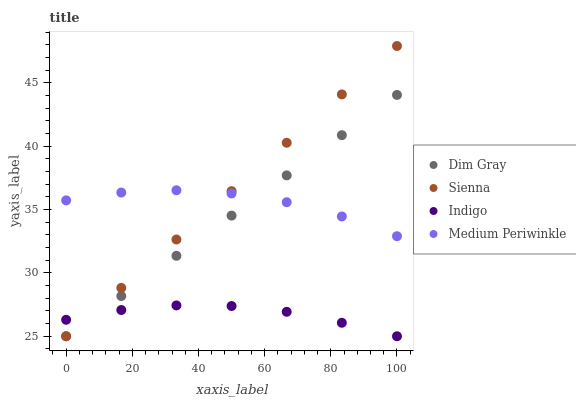Does Indigo have the minimum area under the curve?
Answer yes or no. Yes. Does Sienna have the maximum area under the curve?
Answer yes or no. Yes. Does Medium Periwinkle have the minimum area under the curve?
Answer yes or no. No. Does Medium Periwinkle have the maximum area under the curve?
Answer yes or no. No. Is Sienna the smoothest?
Answer yes or no. Yes. Is Medium Periwinkle the roughest?
Answer yes or no. Yes. Is Dim Gray the smoothest?
Answer yes or no. No. Is Dim Gray the roughest?
Answer yes or no. No. Does Sienna have the lowest value?
Answer yes or no. Yes. Does Medium Periwinkle have the lowest value?
Answer yes or no. No. Does Sienna have the highest value?
Answer yes or no. Yes. Does Medium Periwinkle have the highest value?
Answer yes or no. No. Is Indigo less than Medium Periwinkle?
Answer yes or no. Yes. Is Medium Periwinkle greater than Indigo?
Answer yes or no. Yes. Does Indigo intersect Sienna?
Answer yes or no. Yes. Is Indigo less than Sienna?
Answer yes or no. No. Is Indigo greater than Sienna?
Answer yes or no. No. Does Indigo intersect Medium Periwinkle?
Answer yes or no. No. 